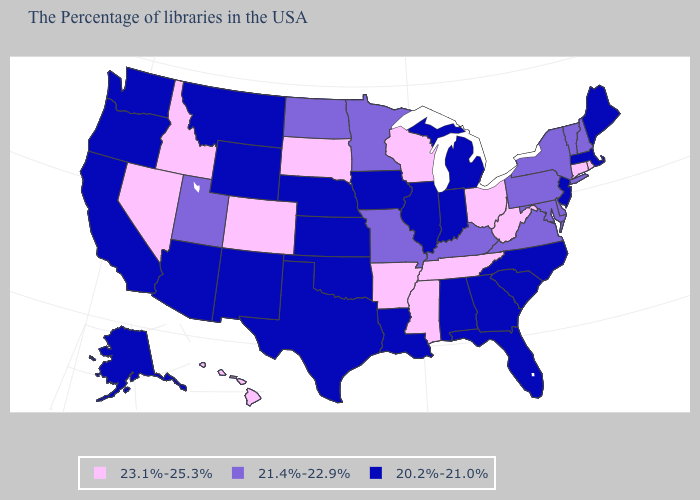How many symbols are there in the legend?
Short answer required. 3. What is the lowest value in the USA?
Write a very short answer. 20.2%-21.0%. Among the states that border Oklahoma , which have the lowest value?
Give a very brief answer. Kansas, Texas, New Mexico. Is the legend a continuous bar?
Short answer required. No. What is the lowest value in the USA?
Quick response, please. 20.2%-21.0%. Name the states that have a value in the range 20.2%-21.0%?
Write a very short answer. Maine, Massachusetts, New Jersey, North Carolina, South Carolina, Florida, Georgia, Michigan, Indiana, Alabama, Illinois, Louisiana, Iowa, Kansas, Nebraska, Oklahoma, Texas, Wyoming, New Mexico, Montana, Arizona, California, Washington, Oregon, Alaska. What is the highest value in the USA?
Keep it brief. 23.1%-25.3%. Among the states that border Oklahoma , does Kansas have the lowest value?
Write a very short answer. Yes. What is the value of Nebraska?
Be succinct. 20.2%-21.0%. What is the lowest value in the South?
Quick response, please. 20.2%-21.0%. Does the map have missing data?
Short answer required. No. Does the map have missing data?
Keep it brief. No. Which states have the lowest value in the Northeast?
Be succinct. Maine, Massachusetts, New Jersey. What is the lowest value in states that border Michigan?
Be succinct. 20.2%-21.0%. What is the lowest value in the Northeast?
Be succinct. 20.2%-21.0%. 